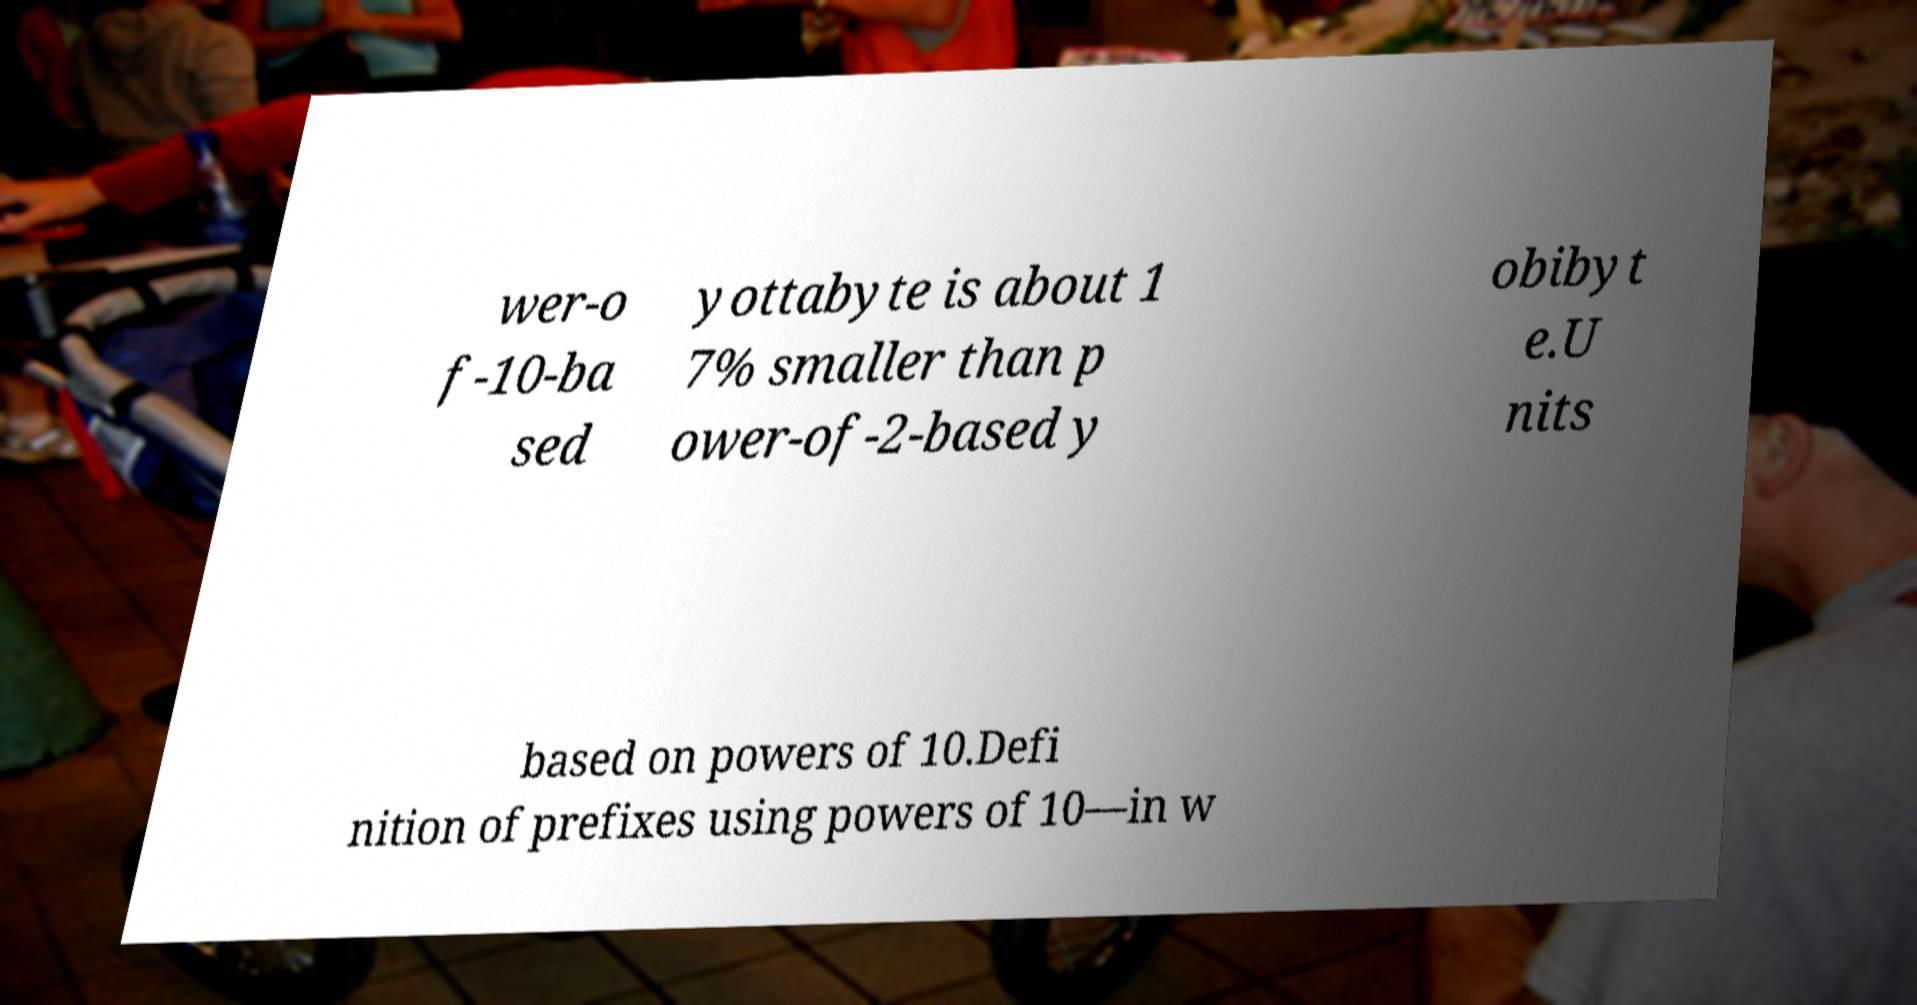Could you extract and type out the text from this image? wer-o f-10-ba sed yottabyte is about 1 7% smaller than p ower-of-2-based y obibyt e.U nits based on powers of 10.Defi nition of prefixes using powers of 10—in w 